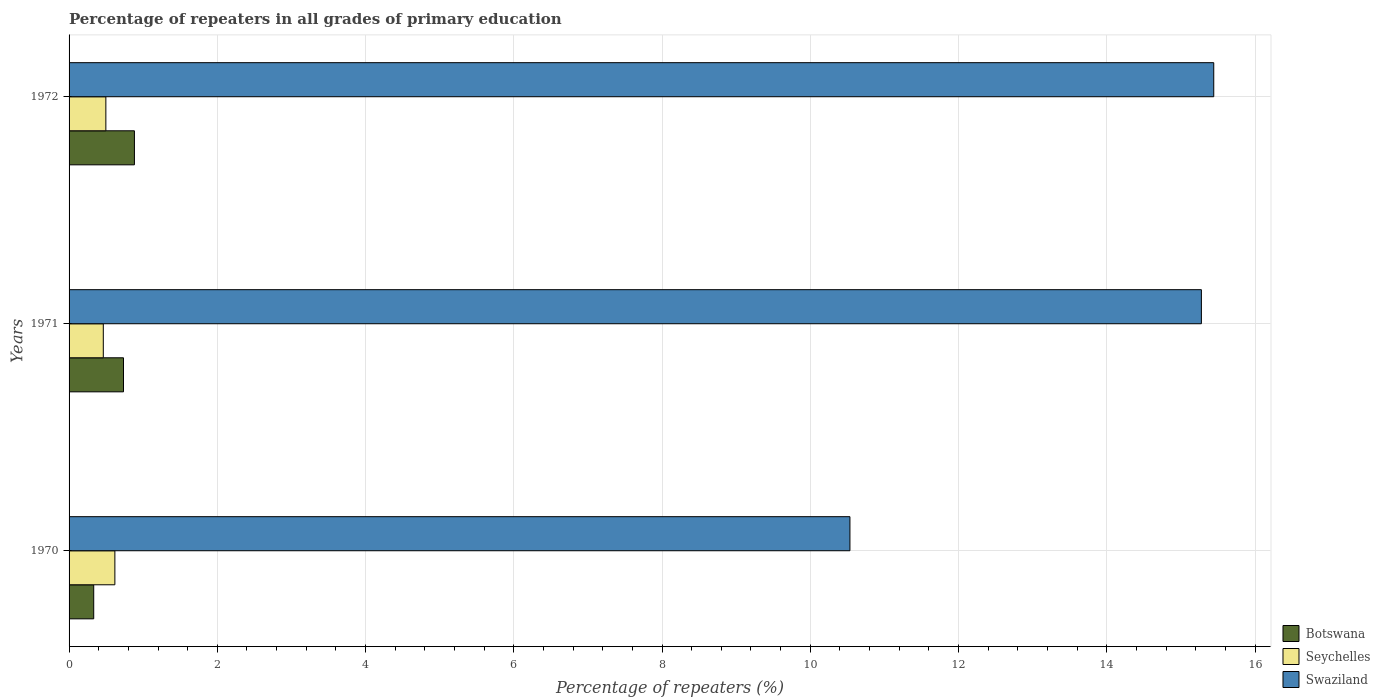How many different coloured bars are there?
Offer a terse response. 3. How many groups of bars are there?
Your response must be concise. 3. Are the number of bars per tick equal to the number of legend labels?
Your answer should be compact. Yes. Are the number of bars on each tick of the Y-axis equal?
Your response must be concise. Yes. How many bars are there on the 2nd tick from the top?
Give a very brief answer. 3. What is the label of the 1st group of bars from the top?
Provide a succinct answer. 1972. What is the percentage of repeaters in Botswana in 1972?
Your answer should be very brief. 0.88. Across all years, what is the maximum percentage of repeaters in Seychelles?
Your response must be concise. 0.62. Across all years, what is the minimum percentage of repeaters in Swaziland?
Make the answer very short. 10.54. In which year was the percentage of repeaters in Seychelles minimum?
Make the answer very short. 1971. What is the total percentage of repeaters in Botswana in the graph?
Offer a terse response. 1.95. What is the difference between the percentage of repeaters in Botswana in 1970 and that in 1971?
Keep it short and to the point. -0.4. What is the difference between the percentage of repeaters in Swaziland in 1971 and the percentage of repeaters in Seychelles in 1972?
Provide a short and direct response. 14.78. What is the average percentage of repeaters in Seychelles per year?
Offer a terse response. 0.53. In the year 1970, what is the difference between the percentage of repeaters in Botswana and percentage of repeaters in Seychelles?
Your response must be concise. -0.29. What is the ratio of the percentage of repeaters in Swaziland in 1971 to that in 1972?
Keep it short and to the point. 0.99. Is the difference between the percentage of repeaters in Botswana in 1970 and 1972 greater than the difference between the percentage of repeaters in Seychelles in 1970 and 1972?
Offer a terse response. No. What is the difference between the highest and the second highest percentage of repeaters in Seychelles?
Make the answer very short. 0.12. What is the difference between the highest and the lowest percentage of repeaters in Seychelles?
Offer a terse response. 0.16. In how many years, is the percentage of repeaters in Swaziland greater than the average percentage of repeaters in Swaziland taken over all years?
Ensure brevity in your answer.  2. Is the sum of the percentage of repeaters in Swaziland in 1970 and 1972 greater than the maximum percentage of repeaters in Seychelles across all years?
Make the answer very short. Yes. What does the 3rd bar from the top in 1970 represents?
Your response must be concise. Botswana. What does the 3rd bar from the bottom in 1970 represents?
Keep it short and to the point. Swaziland. What is the difference between two consecutive major ticks on the X-axis?
Your answer should be very brief. 2. Are the values on the major ticks of X-axis written in scientific E-notation?
Provide a short and direct response. No. Does the graph contain any zero values?
Your response must be concise. No. How many legend labels are there?
Your answer should be compact. 3. How are the legend labels stacked?
Offer a very short reply. Vertical. What is the title of the graph?
Provide a succinct answer. Percentage of repeaters in all grades of primary education. Does "Congo (Republic)" appear as one of the legend labels in the graph?
Your answer should be very brief. No. What is the label or title of the X-axis?
Keep it short and to the point. Percentage of repeaters (%). What is the Percentage of repeaters (%) of Botswana in 1970?
Your answer should be compact. 0.33. What is the Percentage of repeaters (%) in Seychelles in 1970?
Provide a succinct answer. 0.62. What is the Percentage of repeaters (%) in Swaziland in 1970?
Your answer should be compact. 10.54. What is the Percentage of repeaters (%) of Botswana in 1971?
Provide a short and direct response. 0.73. What is the Percentage of repeaters (%) of Seychelles in 1971?
Your answer should be compact. 0.46. What is the Percentage of repeaters (%) of Swaziland in 1971?
Ensure brevity in your answer.  15.28. What is the Percentage of repeaters (%) of Botswana in 1972?
Give a very brief answer. 0.88. What is the Percentage of repeaters (%) of Seychelles in 1972?
Provide a short and direct response. 0.5. What is the Percentage of repeaters (%) of Swaziland in 1972?
Make the answer very short. 15.44. Across all years, what is the maximum Percentage of repeaters (%) of Botswana?
Your answer should be compact. 0.88. Across all years, what is the maximum Percentage of repeaters (%) in Seychelles?
Make the answer very short. 0.62. Across all years, what is the maximum Percentage of repeaters (%) in Swaziland?
Your answer should be very brief. 15.44. Across all years, what is the minimum Percentage of repeaters (%) in Botswana?
Provide a succinct answer. 0.33. Across all years, what is the minimum Percentage of repeaters (%) in Seychelles?
Your response must be concise. 0.46. Across all years, what is the minimum Percentage of repeaters (%) of Swaziland?
Your answer should be compact. 10.54. What is the total Percentage of repeaters (%) in Botswana in the graph?
Your answer should be compact. 1.95. What is the total Percentage of repeaters (%) in Seychelles in the graph?
Your response must be concise. 1.58. What is the total Percentage of repeaters (%) of Swaziland in the graph?
Give a very brief answer. 41.26. What is the difference between the Percentage of repeaters (%) in Botswana in 1970 and that in 1971?
Offer a terse response. -0.4. What is the difference between the Percentage of repeaters (%) of Seychelles in 1970 and that in 1971?
Offer a very short reply. 0.16. What is the difference between the Percentage of repeaters (%) of Swaziland in 1970 and that in 1971?
Offer a terse response. -4.74. What is the difference between the Percentage of repeaters (%) in Botswana in 1970 and that in 1972?
Ensure brevity in your answer.  -0.55. What is the difference between the Percentage of repeaters (%) of Seychelles in 1970 and that in 1972?
Provide a short and direct response. 0.12. What is the difference between the Percentage of repeaters (%) in Swaziland in 1970 and that in 1972?
Offer a terse response. -4.91. What is the difference between the Percentage of repeaters (%) in Botswana in 1971 and that in 1972?
Keep it short and to the point. -0.15. What is the difference between the Percentage of repeaters (%) in Seychelles in 1971 and that in 1972?
Provide a succinct answer. -0.03. What is the difference between the Percentage of repeaters (%) in Botswana in 1970 and the Percentage of repeaters (%) in Seychelles in 1971?
Give a very brief answer. -0.13. What is the difference between the Percentage of repeaters (%) of Botswana in 1970 and the Percentage of repeaters (%) of Swaziland in 1971?
Your answer should be compact. -14.94. What is the difference between the Percentage of repeaters (%) in Seychelles in 1970 and the Percentage of repeaters (%) in Swaziland in 1971?
Ensure brevity in your answer.  -14.66. What is the difference between the Percentage of repeaters (%) of Botswana in 1970 and the Percentage of repeaters (%) of Seychelles in 1972?
Your answer should be very brief. -0.16. What is the difference between the Percentage of repeaters (%) in Botswana in 1970 and the Percentage of repeaters (%) in Swaziland in 1972?
Offer a terse response. -15.11. What is the difference between the Percentage of repeaters (%) in Seychelles in 1970 and the Percentage of repeaters (%) in Swaziland in 1972?
Offer a very short reply. -14.83. What is the difference between the Percentage of repeaters (%) in Botswana in 1971 and the Percentage of repeaters (%) in Seychelles in 1972?
Provide a succinct answer. 0.24. What is the difference between the Percentage of repeaters (%) of Botswana in 1971 and the Percentage of repeaters (%) of Swaziland in 1972?
Your response must be concise. -14.71. What is the difference between the Percentage of repeaters (%) in Seychelles in 1971 and the Percentage of repeaters (%) in Swaziland in 1972?
Provide a short and direct response. -14.98. What is the average Percentage of repeaters (%) of Botswana per year?
Give a very brief answer. 0.65. What is the average Percentage of repeaters (%) in Seychelles per year?
Offer a terse response. 0.53. What is the average Percentage of repeaters (%) in Swaziland per year?
Provide a short and direct response. 13.75. In the year 1970, what is the difference between the Percentage of repeaters (%) of Botswana and Percentage of repeaters (%) of Seychelles?
Ensure brevity in your answer.  -0.29. In the year 1970, what is the difference between the Percentage of repeaters (%) of Botswana and Percentage of repeaters (%) of Swaziland?
Your answer should be very brief. -10.2. In the year 1970, what is the difference between the Percentage of repeaters (%) in Seychelles and Percentage of repeaters (%) in Swaziland?
Give a very brief answer. -9.92. In the year 1971, what is the difference between the Percentage of repeaters (%) in Botswana and Percentage of repeaters (%) in Seychelles?
Offer a terse response. 0.27. In the year 1971, what is the difference between the Percentage of repeaters (%) of Botswana and Percentage of repeaters (%) of Swaziland?
Your answer should be very brief. -14.54. In the year 1971, what is the difference between the Percentage of repeaters (%) in Seychelles and Percentage of repeaters (%) in Swaziland?
Offer a terse response. -14.81. In the year 1972, what is the difference between the Percentage of repeaters (%) of Botswana and Percentage of repeaters (%) of Seychelles?
Your answer should be compact. 0.39. In the year 1972, what is the difference between the Percentage of repeaters (%) in Botswana and Percentage of repeaters (%) in Swaziland?
Ensure brevity in your answer.  -14.56. In the year 1972, what is the difference between the Percentage of repeaters (%) of Seychelles and Percentage of repeaters (%) of Swaziland?
Keep it short and to the point. -14.95. What is the ratio of the Percentage of repeaters (%) in Botswana in 1970 to that in 1971?
Your response must be concise. 0.45. What is the ratio of the Percentage of repeaters (%) in Seychelles in 1970 to that in 1971?
Offer a very short reply. 1.34. What is the ratio of the Percentage of repeaters (%) of Swaziland in 1970 to that in 1971?
Your answer should be very brief. 0.69. What is the ratio of the Percentage of repeaters (%) in Botswana in 1970 to that in 1972?
Your response must be concise. 0.38. What is the ratio of the Percentage of repeaters (%) in Seychelles in 1970 to that in 1972?
Offer a terse response. 1.25. What is the ratio of the Percentage of repeaters (%) in Swaziland in 1970 to that in 1972?
Your answer should be very brief. 0.68. What is the ratio of the Percentage of repeaters (%) of Botswana in 1971 to that in 1972?
Your answer should be very brief. 0.83. What is the ratio of the Percentage of repeaters (%) in Seychelles in 1971 to that in 1972?
Make the answer very short. 0.93. What is the ratio of the Percentage of repeaters (%) in Swaziland in 1971 to that in 1972?
Ensure brevity in your answer.  0.99. What is the difference between the highest and the second highest Percentage of repeaters (%) of Botswana?
Give a very brief answer. 0.15. What is the difference between the highest and the second highest Percentage of repeaters (%) in Seychelles?
Keep it short and to the point. 0.12. What is the difference between the highest and the second highest Percentage of repeaters (%) in Swaziland?
Ensure brevity in your answer.  0.17. What is the difference between the highest and the lowest Percentage of repeaters (%) in Botswana?
Your answer should be compact. 0.55. What is the difference between the highest and the lowest Percentage of repeaters (%) in Seychelles?
Your response must be concise. 0.16. What is the difference between the highest and the lowest Percentage of repeaters (%) in Swaziland?
Ensure brevity in your answer.  4.91. 